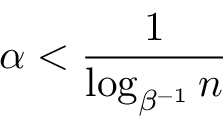<formula> <loc_0><loc_0><loc_500><loc_500>\alpha < \frac { 1 } { \log _ { \beta ^ { - 1 } } n }</formula> 